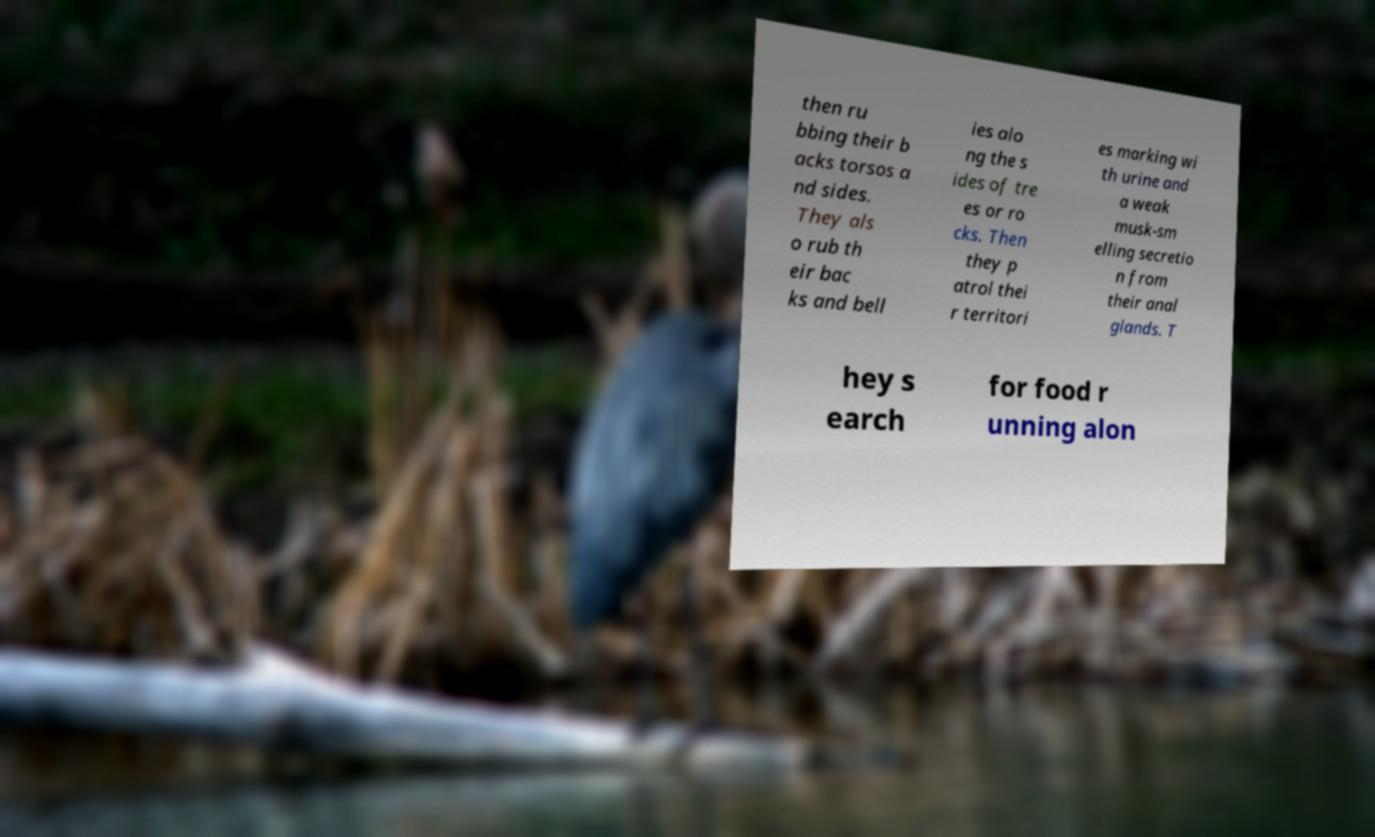Could you extract and type out the text from this image? then ru bbing their b acks torsos a nd sides. They als o rub th eir bac ks and bell ies alo ng the s ides of tre es or ro cks. Then they p atrol thei r territori es marking wi th urine and a weak musk-sm elling secretio n from their anal glands. T hey s earch for food r unning alon 